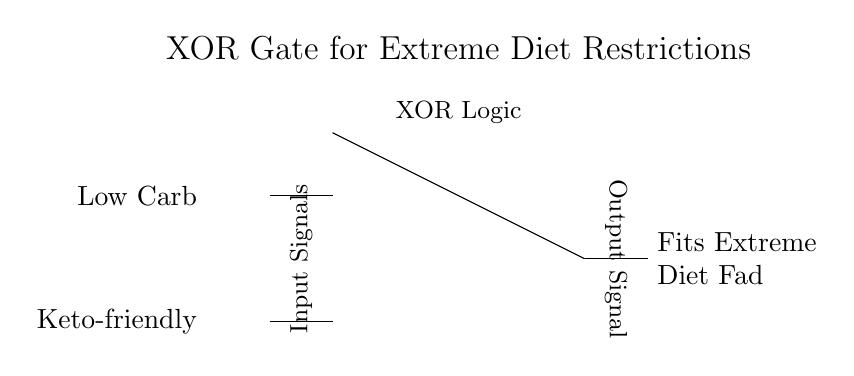What are the two input signals to the XOR gate? The input signals are labeled as Low Carb and Keto-friendly, which indicate the dietary restrictions.
Answer: Low Carb, Keto-friendly What does the output of the XOR gate represent? The output labeled "Fits Extreme Diet Fad" signifies whether the food item adheres to specified extreme diet criteria based on the input signals.
Answer: Fits Extreme Diet Fad How many input signals are there in this circuit? There are two input signals presented that feed into the XOR gate, as indicated in the diagram.
Answer: 2 What logic operation is performed by this gate? The gate in question is an XOR gate, which outputs true only when one of the inputs is true and the other is false.
Answer: XOR When will the diet fad be considered "fitting"? The diet fad is considered fitting when exactly one of the inputs is true, meaning only one of the dietary restrictions is satisfied.
Answer: One input true What type of gate is used in this system? The gate used is specifically an XOR (exclusive OR) gate, which is known for its unique output behavior.
Answer: XOR gate 